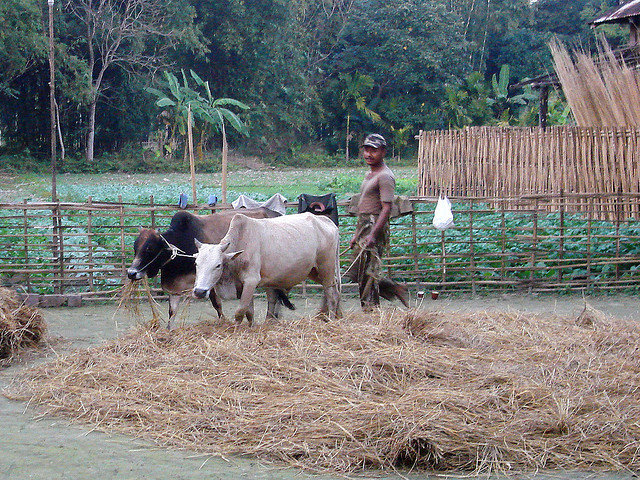Can you tell what time of day it might be in this location? It's difficult to determine the exact time of day with precision just from the image, but based on the bright ambient light and long shadows cast by the subjects, it could be in the late afternoon. The sunlight is not overly harsh, suggesting that it is not the middle of the day when the sun would be at its zenith. 